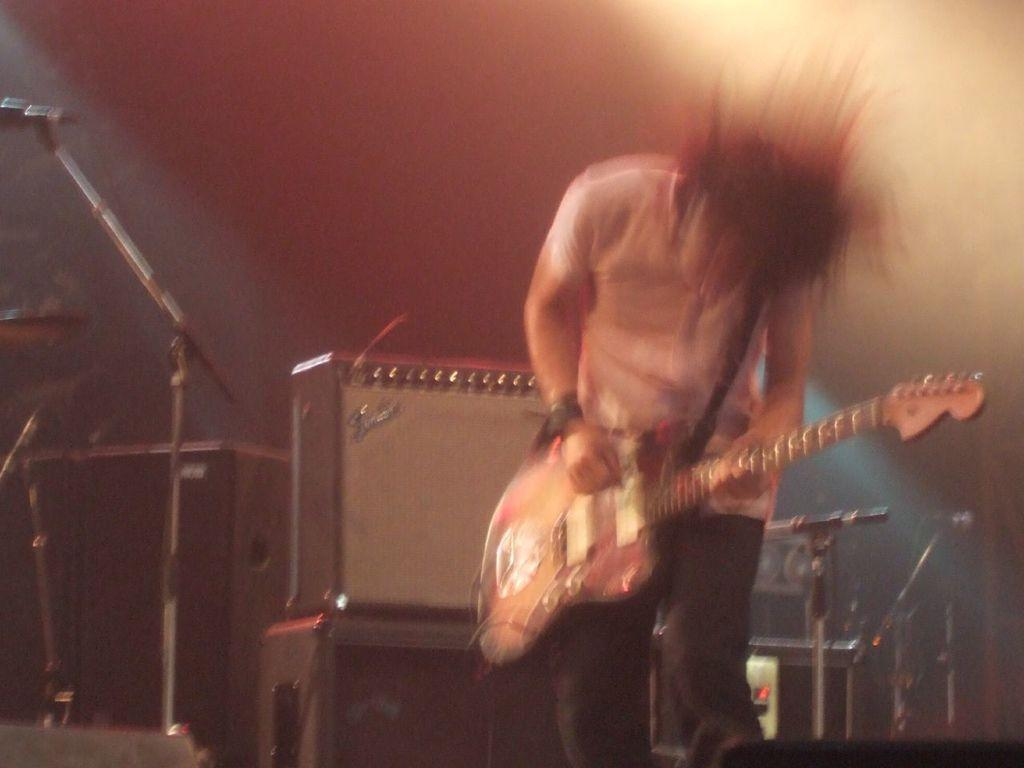What is the person in the image doing? The person is playing a guitar. What object is located at the left side of the image? There is a microphone at the left side of the image. Where are the toys located in the image? There are no toys present in the image. What type of monkey can be seen playing the guitar in the image? There is no monkey present in the image; it is a person playing the guitar. 